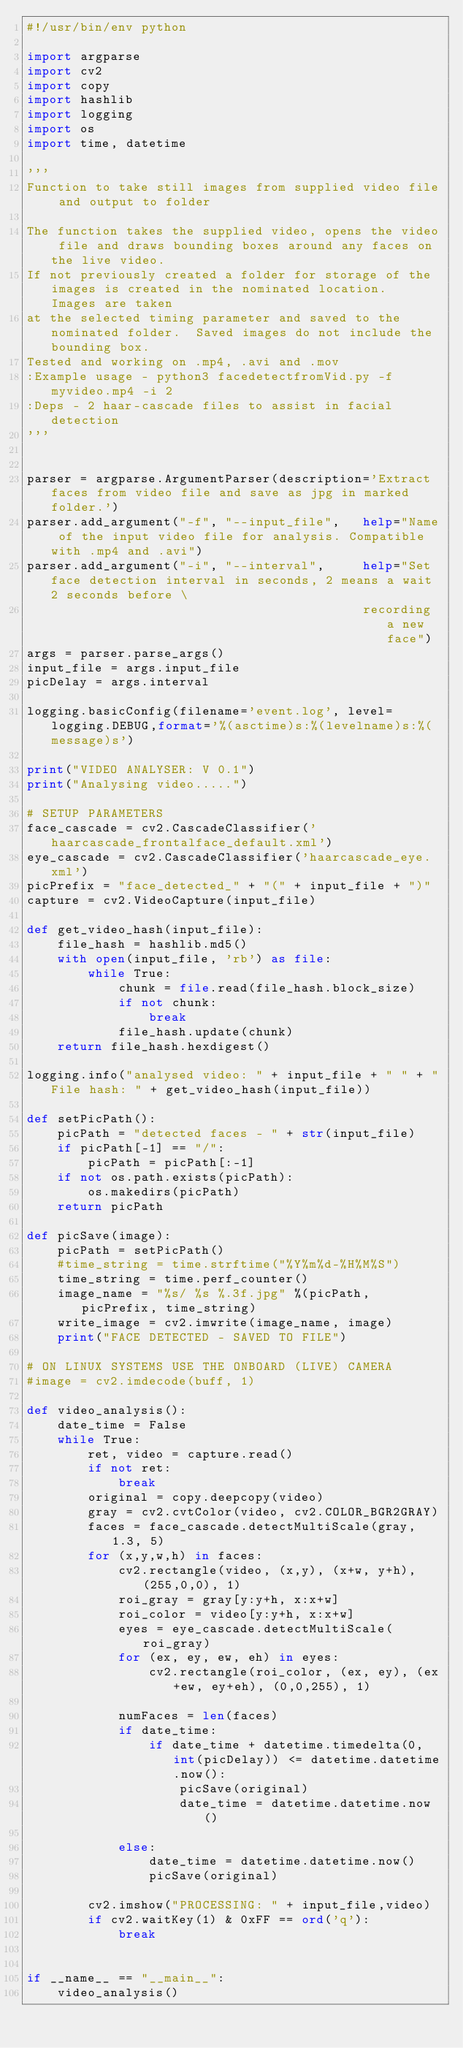<code> <loc_0><loc_0><loc_500><loc_500><_Python_>#!/usr/bin/env python

import argparse
import cv2
import copy
import hashlib
import logging
import os
import time, datetime

'''
Function to take still images from supplied video file and output to folder 

The function takes the supplied video, opens the video file and draws bounding boxes around any faces on the live video.
If not previously created a folder for storage of the images is created in the nominated location.  Images are taken 
at the selected timing parameter and saved to the nominated folder.  Saved images do not include the bounding box. 
Tested and working on .mp4, .avi and .mov
:Example usage - python3 facedetectfromVid.py -f myvideo.mp4 -i 2 
:Deps - 2 haar-cascade files to assist in facial detection 
'''


parser = argparse.ArgumentParser(description='Extract faces from video file and save as jpg in marked folder.')
parser.add_argument("-f", "--input_file", 	help="Name of the input video file for analysis. Compatible with .mp4 and .avi")
parser.add_argument("-i", "--interval", 	help="Set face detection interval in seconds, 2 means a wait 2 seconds before \
											recording a new face")
args = parser.parse_args()
input_file = args.input_file
picDelay = args.interval

logging.basicConfig(filename='event.log', level=logging.DEBUG,format='%(asctime)s:%(levelname)s:%(message)s')

print("VIDEO ANALYSER: V 0.1")
print("Analysing video.....")

# SETUP PARAMETERS
face_cascade = cv2.CascadeClassifier('haarcascade_frontalface_default.xml')
eye_cascade = cv2.CascadeClassifier('haarcascade_eye.xml')
picPrefix = "face_detected_" + "(" + input_file + ")"
capture = cv2.VideoCapture(input_file)

def get_video_hash(input_file):
    file_hash = hashlib.md5()
    with open(input_file, 'rb') as file:
        while True:
            chunk = file.read(file_hash.block_size)
            if not chunk:
                break
            file_hash.update(chunk)
    return file_hash.hexdigest()

logging.info("analysed video: " + input_file + " " + "File hash: " + get_video_hash(input_file))

def setPicPath():
	picPath = "detected faces - " + str(input_file)
	if picPath[-1] == "/":
		picPath = picPath[:-1]
	if not os.path.exists(picPath):
		os.makedirs(picPath)
	return picPath

def picSave(image):
	picPath = setPicPath()
	#time_string = time.strftime("%Y%m%d-%H%M%S")
	time_string = time.perf_counter()
	image_name = "%s/ %s %.3f.jpg" %(picPath, picPrefix, time_string)
	write_image = cv2.imwrite(image_name, image)	
	print("FACE DETECTED - SAVED TO FILE")

# ON LINUX SYSTEMS USE THE ONBOARD (LIVE) CAMERA
#image = cv2.imdecode(buff, 1)

def video_analysis():
	date_time = False
	while True:
		ret, video = capture.read()
		if not ret:
			break
		original = copy.deepcopy(video)
		gray = cv2.cvtColor(video, cv2.COLOR_BGR2GRAY)
		faces = face_cascade.detectMultiScale(gray, 1.3, 5)
		for (x,y,w,h) in faces:
			cv2.rectangle(video, (x,y), (x+w, y+h), (255,0,0), 1)
			roi_gray = gray[y:y+h, x:x+w] 
			roi_color = video[y:y+h, x:x+w]
			eyes = eye_cascade.detectMultiScale(roi_gray)
			for (ex, ey, ew, eh) in eyes:
				cv2.rectangle(roi_color, (ex, ey), (ex+ew, ey+eh), (0,0,255), 1)

			numFaces = len(faces)
			if date_time:
				if date_time + datetime.timedelta(0, int(picDelay)) <= datetime.datetime.now():
					picSave(original)
					date_time = datetime.datetime.now()

			else:
				date_time = datetime.datetime.now()
				picSave(original)

		cv2.imshow("PROCESSING: " + input_file,video)
		if cv2.waitKey(1) & 0xFF == ord('q'):
			break

        
if __name__ == "__main__":
	video_analysis()
</code> 